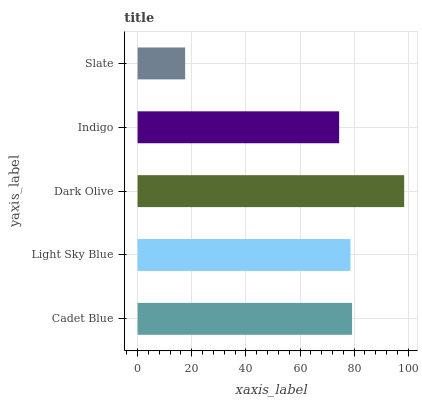Is Slate the minimum?
Answer yes or no. Yes. Is Dark Olive the maximum?
Answer yes or no. Yes. Is Light Sky Blue the minimum?
Answer yes or no. No. Is Light Sky Blue the maximum?
Answer yes or no. No. Is Cadet Blue greater than Light Sky Blue?
Answer yes or no. Yes. Is Light Sky Blue less than Cadet Blue?
Answer yes or no. Yes. Is Light Sky Blue greater than Cadet Blue?
Answer yes or no. No. Is Cadet Blue less than Light Sky Blue?
Answer yes or no. No. Is Light Sky Blue the high median?
Answer yes or no. Yes. Is Light Sky Blue the low median?
Answer yes or no. Yes. Is Dark Olive the high median?
Answer yes or no. No. Is Slate the low median?
Answer yes or no. No. 